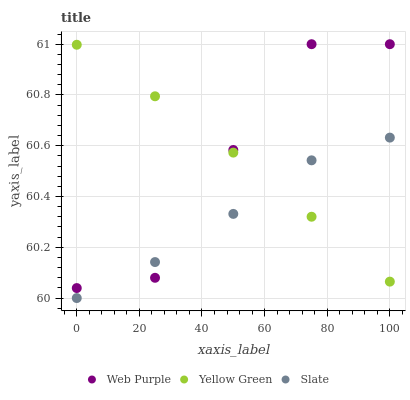Does Slate have the minimum area under the curve?
Answer yes or no. Yes. Does Yellow Green have the maximum area under the curve?
Answer yes or no. Yes. Does Yellow Green have the minimum area under the curve?
Answer yes or no. No. Does Slate have the maximum area under the curve?
Answer yes or no. No. Is Yellow Green the smoothest?
Answer yes or no. Yes. Is Web Purple the roughest?
Answer yes or no. Yes. Is Slate the smoothest?
Answer yes or no. No. Is Slate the roughest?
Answer yes or no. No. Does Slate have the lowest value?
Answer yes or no. Yes. Does Yellow Green have the lowest value?
Answer yes or no. No. Does Web Purple have the highest value?
Answer yes or no. Yes. Does Yellow Green have the highest value?
Answer yes or no. No. Does Slate intersect Web Purple?
Answer yes or no. Yes. Is Slate less than Web Purple?
Answer yes or no. No. Is Slate greater than Web Purple?
Answer yes or no. No. 